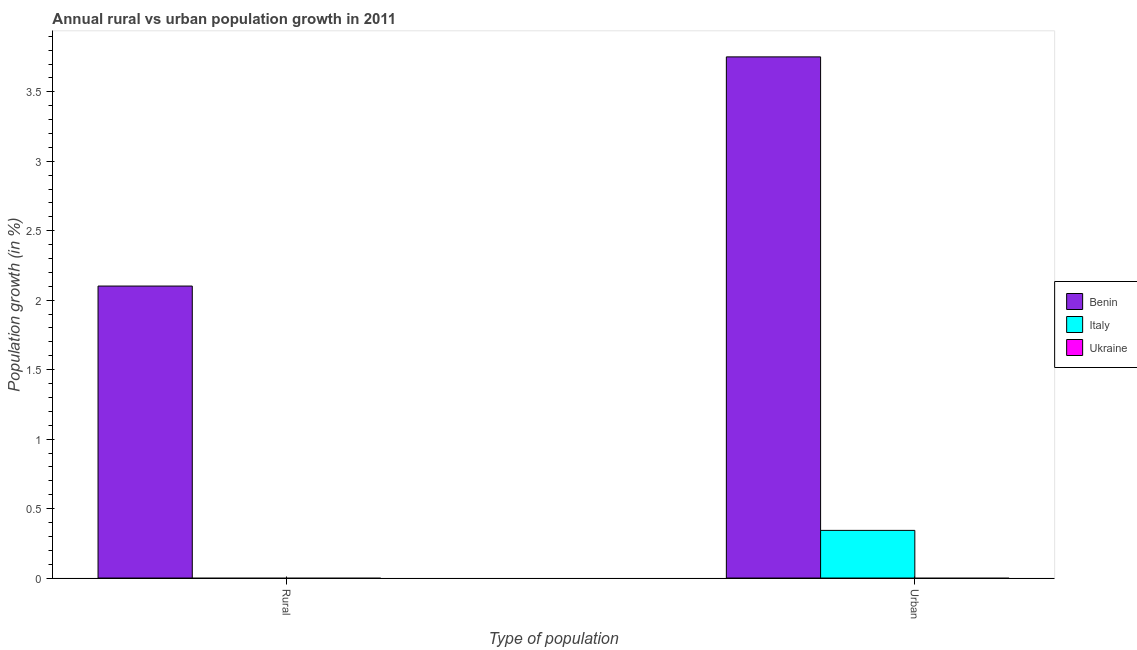How many different coloured bars are there?
Keep it short and to the point. 2. Are the number of bars per tick equal to the number of legend labels?
Your response must be concise. No. Are the number of bars on each tick of the X-axis equal?
Make the answer very short. No. How many bars are there on the 2nd tick from the left?
Keep it short and to the point. 2. How many bars are there on the 2nd tick from the right?
Make the answer very short. 1. What is the label of the 2nd group of bars from the left?
Your answer should be compact. Urban . What is the urban population growth in Italy?
Offer a terse response. 0.34. Across all countries, what is the maximum urban population growth?
Your answer should be very brief. 3.75. In which country was the urban population growth maximum?
Offer a very short reply. Benin. What is the total urban population growth in the graph?
Provide a short and direct response. 4.09. What is the difference between the urban population growth in Italy and that in Benin?
Your response must be concise. -3.41. What is the difference between the rural population growth in Benin and the urban population growth in Italy?
Offer a terse response. 1.76. What is the average urban population growth per country?
Ensure brevity in your answer.  1.36. In how many countries, is the rural population growth greater than 1.4 %?
Offer a very short reply. 1. What is the ratio of the urban population growth in Benin to that in Italy?
Provide a succinct answer. 10.93. In how many countries, is the rural population growth greater than the average rural population growth taken over all countries?
Your answer should be very brief. 1. How many bars are there?
Keep it short and to the point. 3. Are all the bars in the graph horizontal?
Your answer should be very brief. No. Does the graph contain any zero values?
Offer a very short reply. Yes. Does the graph contain grids?
Ensure brevity in your answer.  No. How many legend labels are there?
Make the answer very short. 3. What is the title of the graph?
Your answer should be compact. Annual rural vs urban population growth in 2011. What is the label or title of the X-axis?
Give a very brief answer. Type of population. What is the label or title of the Y-axis?
Provide a succinct answer. Population growth (in %). What is the Population growth (in %) in Benin in Rural?
Your response must be concise. 2.1. What is the Population growth (in %) of Italy in Rural?
Give a very brief answer. 0. What is the Population growth (in %) in Benin in Urban ?
Give a very brief answer. 3.75. What is the Population growth (in %) in Italy in Urban ?
Make the answer very short. 0.34. Across all Type of population, what is the maximum Population growth (in %) in Benin?
Make the answer very short. 3.75. Across all Type of population, what is the maximum Population growth (in %) in Italy?
Make the answer very short. 0.34. Across all Type of population, what is the minimum Population growth (in %) of Benin?
Ensure brevity in your answer.  2.1. What is the total Population growth (in %) in Benin in the graph?
Offer a very short reply. 5.85. What is the total Population growth (in %) in Italy in the graph?
Keep it short and to the point. 0.34. What is the total Population growth (in %) of Ukraine in the graph?
Give a very brief answer. 0. What is the difference between the Population growth (in %) in Benin in Rural and that in Urban ?
Offer a very short reply. -1.65. What is the difference between the Population growth (in %) of Benin in Rural and the Population growth (in %) of Italy in Urban?
Provide a succinct answer. 1.76. What is the average Population growth (in %) in Benin per Type of population?
Provide a short and direct response. 2.93. What is the average Population growth (in %) in Italy per Type of population?
Give a very brief answer. 0.17. What is the difference between the Population growth (in %) of Benin and Population growth (in %) of Italy in Urban ?
Make the answer very short. 3.41. What is the ratio of the Population growth (in %) in Benin in Rural to that in Urban ?
Ensure brevity in your answer.  0.56. What is the difference between the highest and the second highest Population growth (in %) of Benin?
Provide a short and direct response. 1.65. What is the difference between the highest and the lowest Population growth (in %) in Benin?
Provide a succinct answer. 1.65. What is the difference between the highest and the lowest Population growth (in %) of Italy?
Provide a succinct answer. 0.34. 